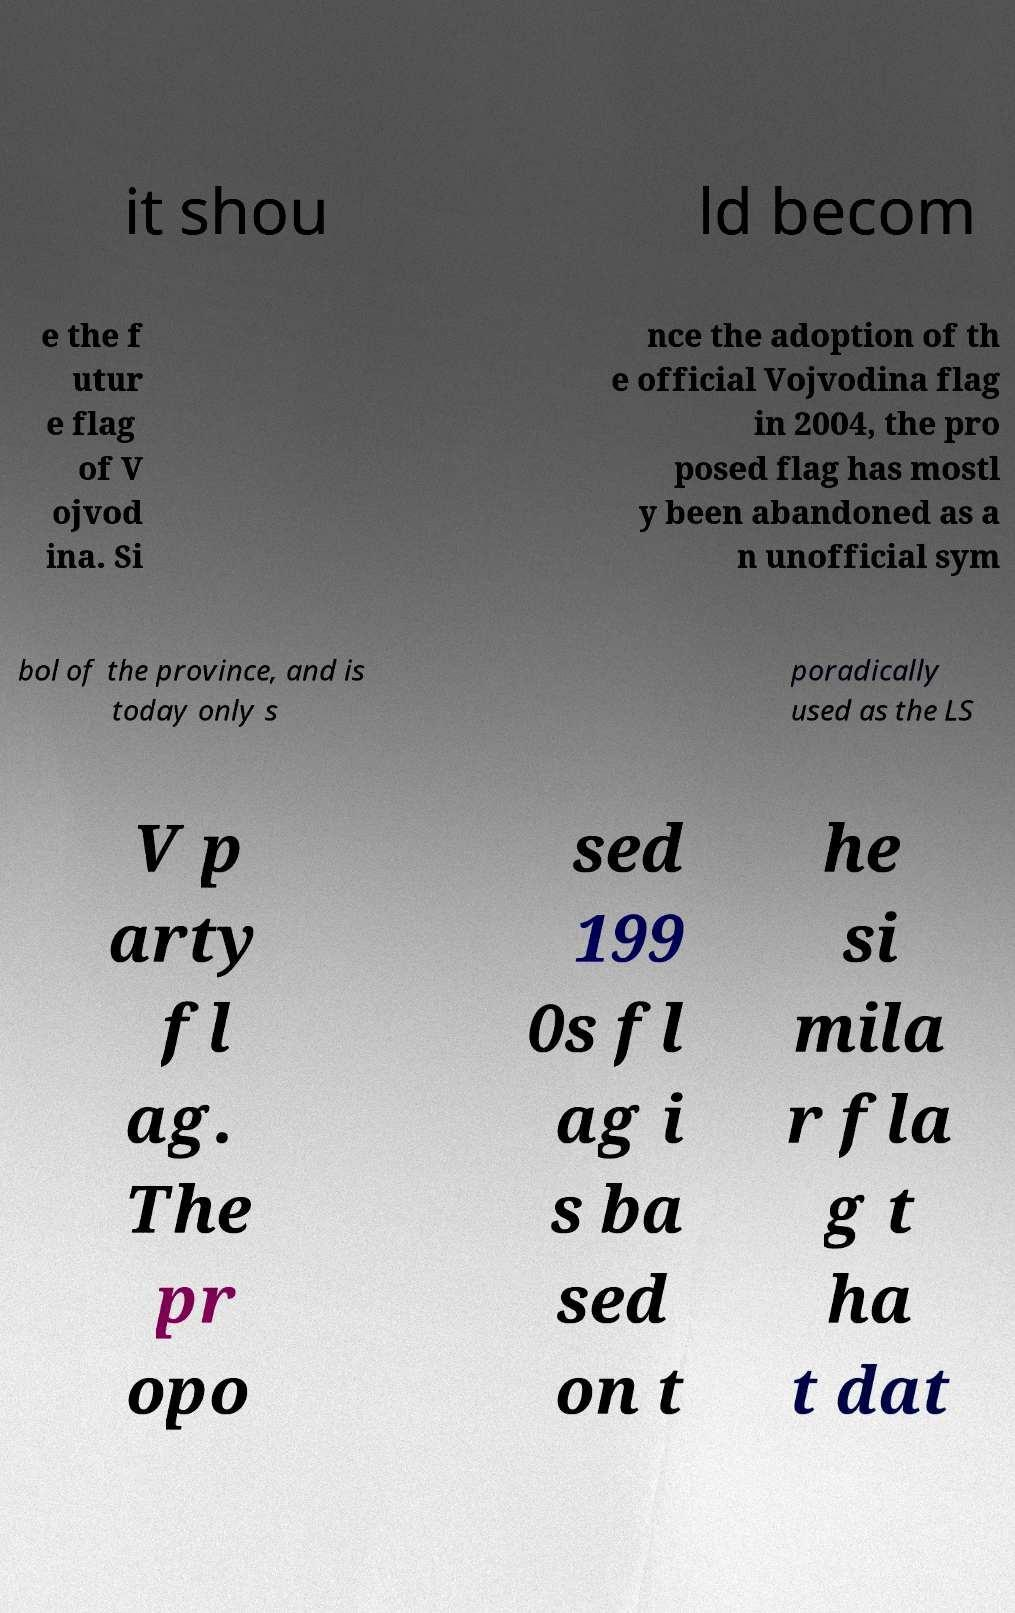What messages or text are displayed in this image? I need them in a readable, typed format. it shou ld becom e the f utur e flag of V ojvod ina. Si nce the adoption of th e official Vojvodina flag in 2004, the pro posed flag has mostl y been abandoned as a n unofficial sym bol of the province, and is today only s poradically used as the LS V p arty fl ag. The pr opo sed 199 0s fl ag i s ba sed on t he si mila r fla g t ha t dat 